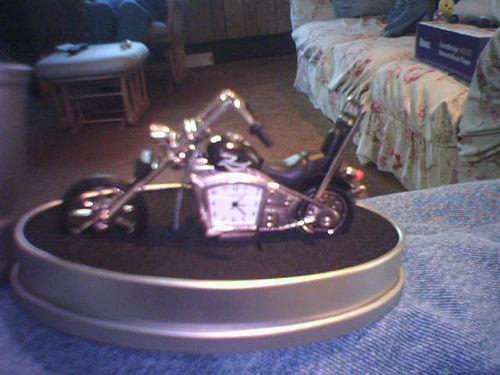How many people are visible?
Give a very brief answer. 2. 